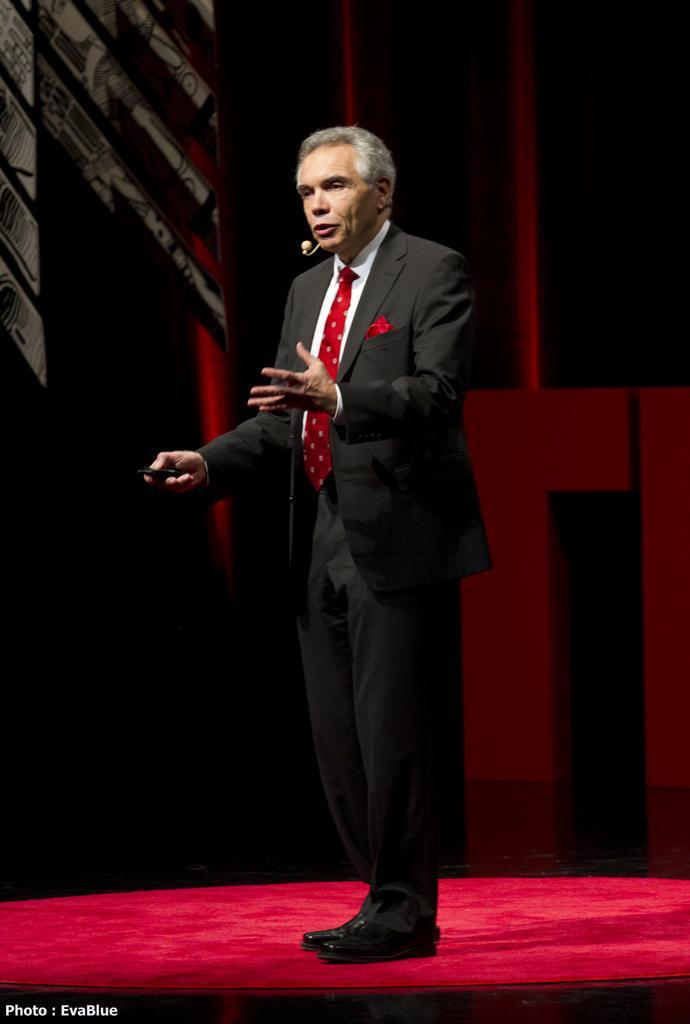In one or two sentences, can you explain what this image depicts? As we can see in the image there is a man wearing black color jacket and the image is little dark. 